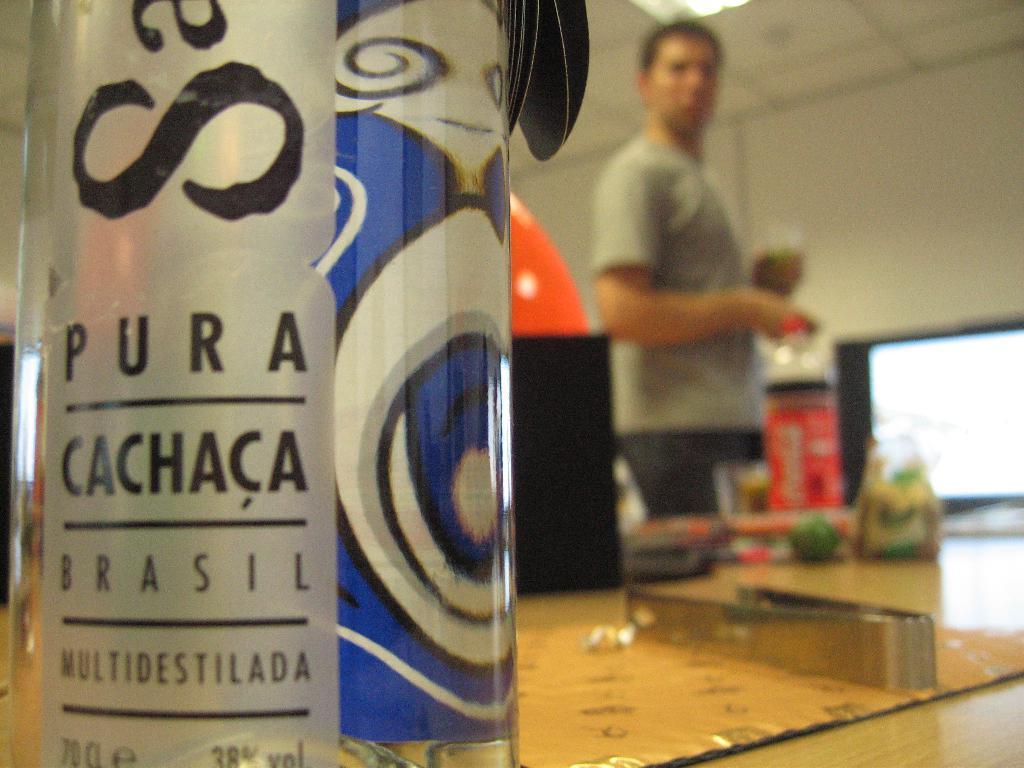What country is mentioned on this bottle?
Give a very brief answer. Brasil. What word is written above the top horizontal line on the bottle?
Give a very brief answer. Pura. 